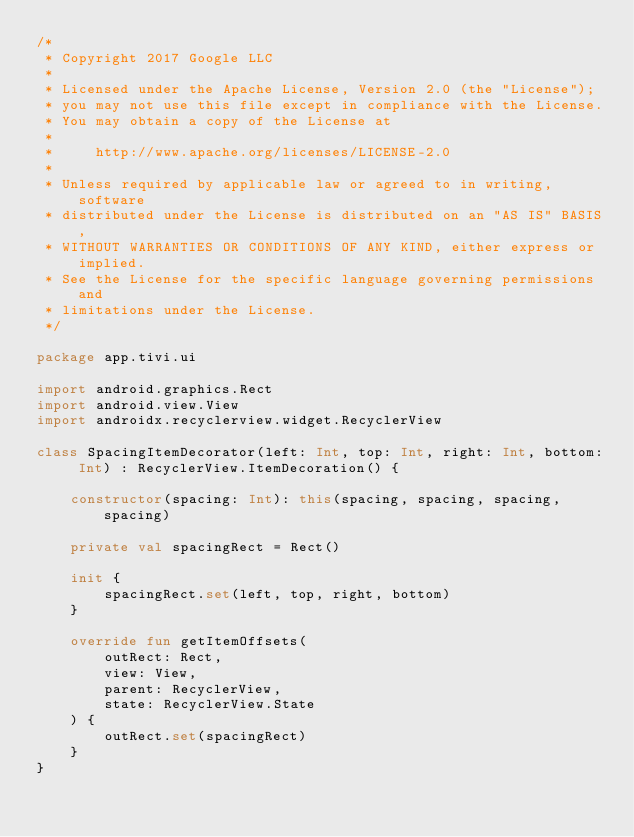<code> <loc_0><loc_0><loc_500><loc_500><_Kotlin_>/*
 * Copyright 2017 Google LLC
 *
 * Licensed under the Apache License, Version 2.0 (the "License");
 * you may not use this file except in compliance with the License.
 * You may obtain a copy of the License at
 *
 *     http://www.apache.org/licenses/LICENSE-2.0
 *
 * Unless required by applicable law or agreed to in writing, software
 * distributed under the License is distributed on an "AS IS" BASIS,
 * WITHOUT WARRANTIES OR CONDITIONS OF ANY KIND, either express or implied.
 * See the License for the specific language governing permissions and
 * limitations under the License.
 */

package app.tivi.ui

import android.graphics.Rect
import android.view.View
import androidx.recyclerview.widget.RecyclerView

class SpacingItemDecorator(left: Int, top: Int, right: Int, bottom: Int) : RecyclerView.ItemDecoration() {

    constructor(spacing: Int): this(spacing, spacing, spacing, spacing)

    private val spacingRect = Rect()

    init {
        spacingRect.set(left, top, right, bottom)
    }

    override fun getItemOffsets(
        outRect: Rect,
        view: View,
        parent: RecyclerView,
        state: RecyclerView.State
    ) {
        outRect.set(spacingRect)
    }
}
</code> 